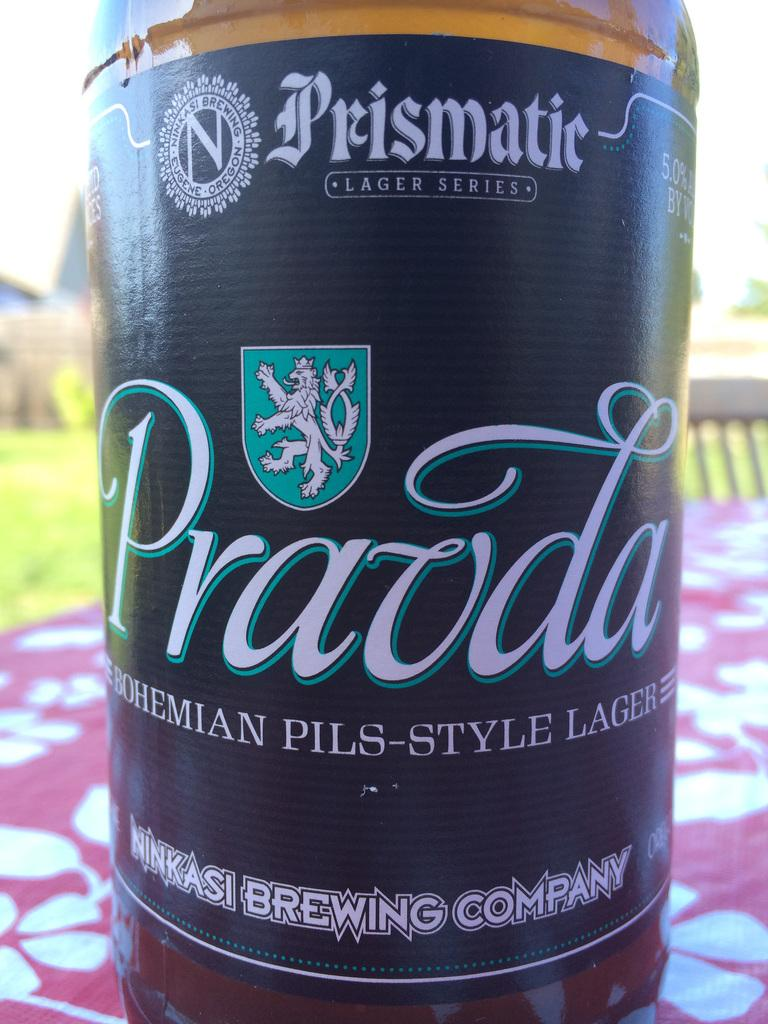<image>
Offer a succinct explanation of the picture presented. A unit of Pravda Bohemian Pils-Style Lager from the Ninkas Brewing Company. 